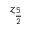<formula> <loc_0><loc_0><loc_500><loc_500>z _ { \frac { 5 } { 2 } }</formula> 